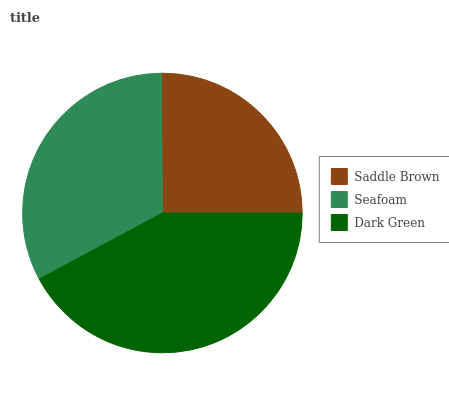Is Saddle Brown the minimum?
Answer yes or no. Yes. Is Dark Green the maximum?
Answer yes or no. Yes. Is Seafoam the minimum?
Answer yes or no. No. Is Seafoam the maximum?
Answer yes or no. No. Is Seafoam greater than Saddle Brown?
Answer yes or no. Yes. Is Saddle Brown less than Seafoam?
Answer yes or no. Yes. Is Saddle Brown greater than Seafoam?
Answer yes or no. No. Is Seafoam less than Saddle Brown?
Answer yes or no. No. Is Seafoam the high median?
Answer yes or no. Yes. Is Seafoam the low median?
Answer yes or no. Yes. Is Dark Green the high median?
Answer yes or no. No. Is Saddle Brown the low median?
Answer yes or no. No. 